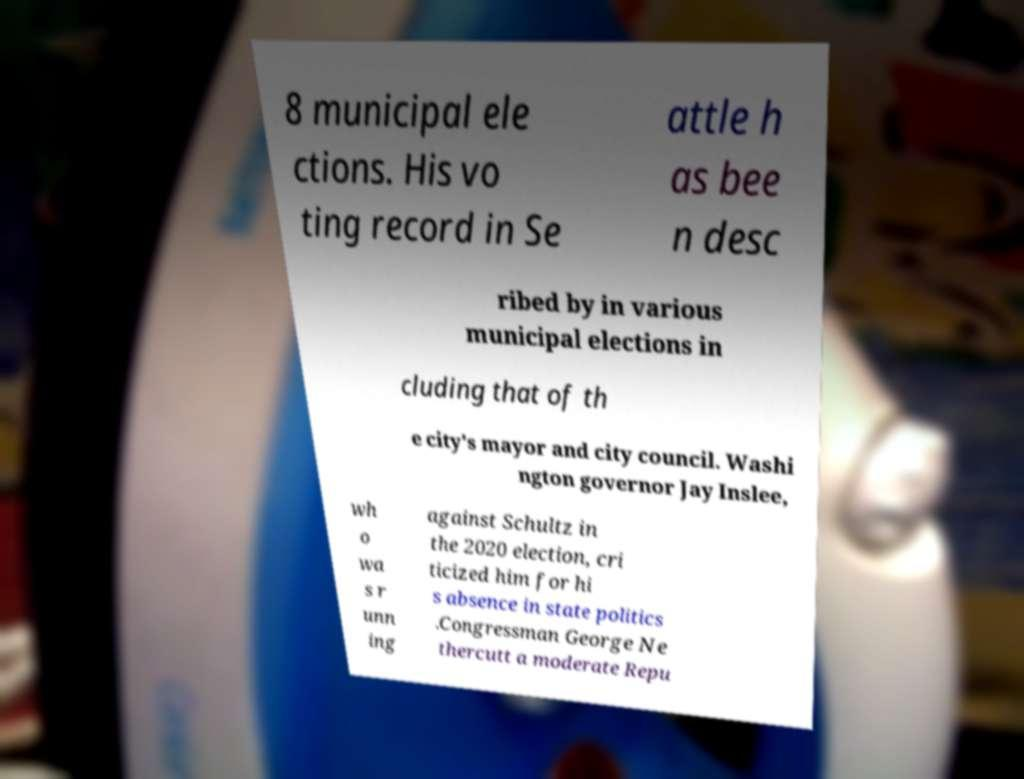I need the written content from this picture converted into text. Can you do that? 8 municipal ele ctions. His vo ting record in Se attle h as bee n desc ribed by in various municipal elections in cluding that of th e city's mayor and city council. Washi ngton governor Jay Inslee, wh o wa s r unn ing against Schultz in the 2020 election, cri ticized him for hi s absence in state politics .Congressman George Ne thercutt a moderate Repu 